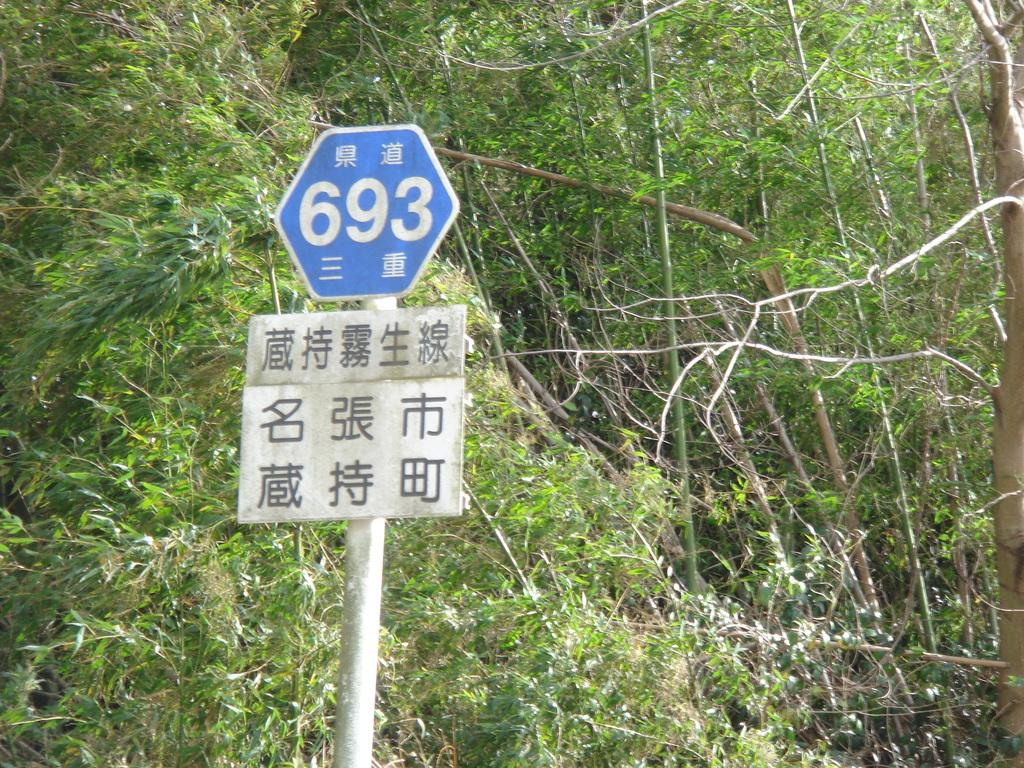What is the main structure in the image? There is a pole with two boards in the image. What can be seen in the background of the image? There are trees in the background of the image. What type of boards are present in the image? There is a white board with text and a blue board with text and numbers in the image. What type of insect is crawling on the white board in the image? There are no insects present on the white board or in the image. What is the reaction of the daughter to the text on the blue board? There is no daughter present in the image, so it is not possible to determine her reaction to the text on the blue board. 